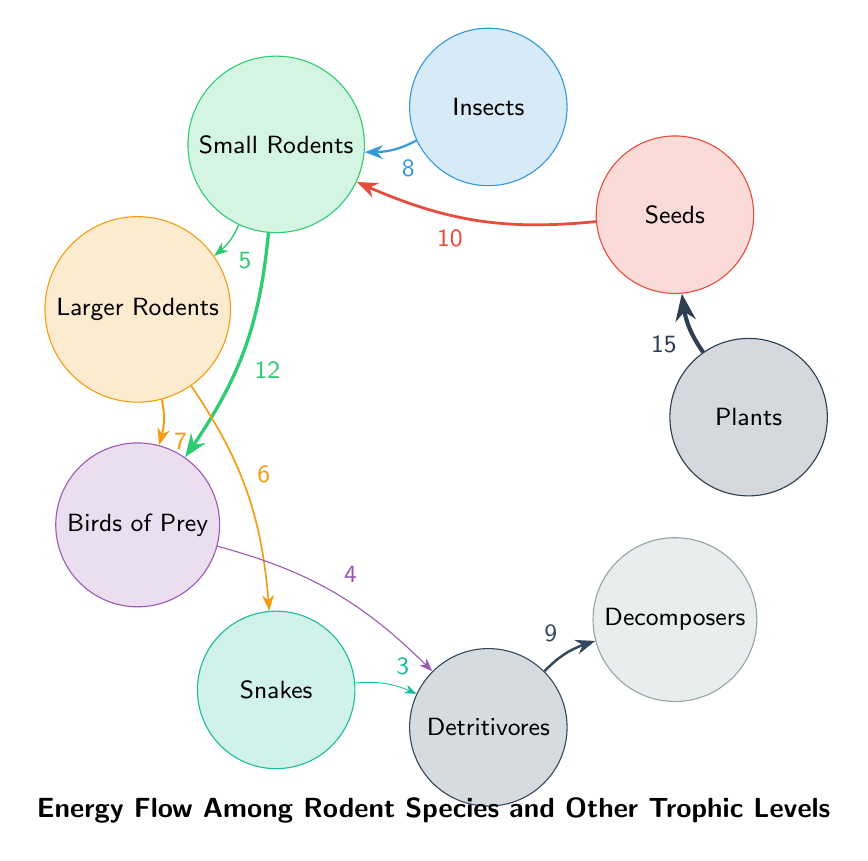What's the total number of nodes in the diagram? The diagram contains nine nodes representing different trophic levels and species, which are Plants, Seeds, Insects, Small Rodents, Larger Rodents, Birds of Prey, Snakes, Detritivores, and Decomposers.
Answer: 9 What is the energy flow value from Plants to Seeds? The diagram indicates a direct link from Plants to Seeds with an energy flow value of 15. This is noted on the arrow connecting these two nodes.
Answer: 15 Which trophic component has the highest energy flow value directing toward Small Rodents? The diagram shows that Seeds have the highest energy flow value of 10 directed toward Small Rodents, as highlighted by the corresponding arrow.
Answer: Seeds What is the total energy flow from Small Rodents to Birds of Prey? The energy flow from Small Rodents to Birds of Prey includes two values: 12 from Small Rodents and 7 from Larger Rodents that are also connected to Birds of Prey. Therefore, the total is 12 + 7 = 19.
Answer: 19 How does the energy flow from Snakes to Detritivores compare to that from Birds of Prey to Detritivores? The diagram shows that energy flows from Snakes to Detritivores with a value of 3, whereas the flow from Birds of Prey to Detritivores is valued at 4. Thus, the flow from Birds of Prey is greater by 1.
Answer: 1 Which node consumes the least amount of energy in the entire flow? The least amount of energy flow consumed is illustrated by the value of 3 from Snakes to Detritivores. This is the lowest value shown on any arrow in the diagram.
Answer: 3 What is the role of Decomposers in the energy flow? Decomposers receive energy from Detritivores, which indicates that they play the role of breaking down organic material, completing the energy flow cycle as shown by the value of 9 between them.
Answer: Breaking down organic material Which two species have a direct competition for energy flow in the form of predation? Small Rodents and Larger Rodents both have arrows pointing to the same predator, Birds of Prey, indicating they compete for the same resource. The energy flows are 12 and 7 respectively.
Answer: Small Rodents and Larger Rodents How many interactions lead to Decomposers? There is only one direct interaction leading to Decomposers, which is from Detritivores with an energy flow value of 9 noted in the diagram.
Answer: 1 